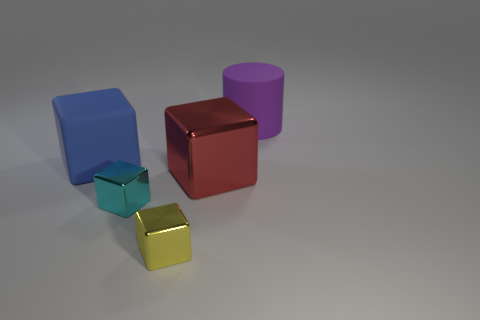Are there any other things that have the same color as the cylinder?
Provide a short and direct response. No. Is there a cyan thing that has the same shape as the blue rubber object?
Provide a short and direct response. Yes. There is another object that is the same size as the cyan object; what is its shape?
Keep it short and to the point. Cube. What is the material of the big block to the right of the rubber object to the left of the small metallic cube that is to the left of the yellow metallic cube?
Ensure brevity in your answer.  Metal. Is the cylinder the same size as the cyan cube?
Your answer should be compact. No. What is the cyan thing made of?
Provide a succinct answer. Metal. There is a tiny shiny thing that is behind the small yellow cube; is it the same shape as the large blue thing?
Give a very brief answer. Yes. What number of objects are either red balls or cyan shiny objects?
Keep it short and to the point. 1. Is the material of the small thing to the right of the tiny cyan metal thing the same as the large red object?
Your answer should be compact. Yes. How big is the purple object?
Your answer should be compact. Large. 